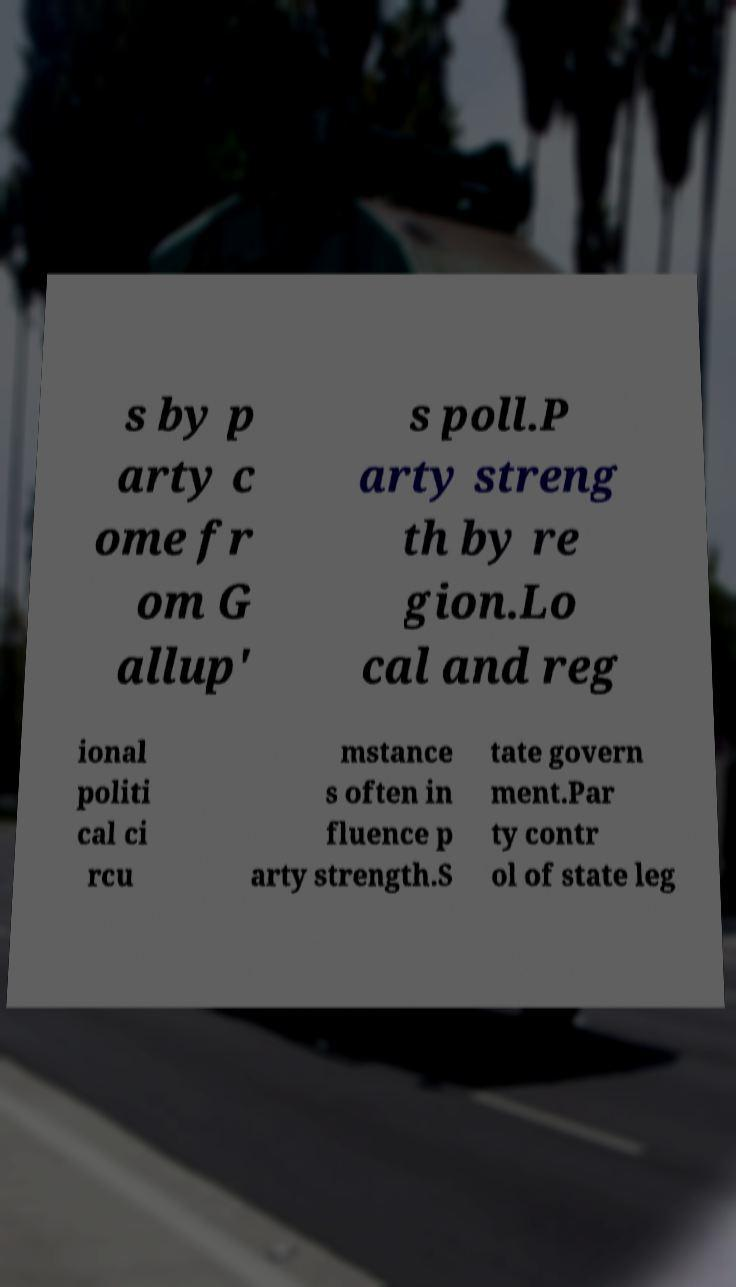For documentation purposes, I need the text within this image transcribed. Could you provide that? s by p arty c ome fr om G allup' s poll.P arty streng th by re gion.Lo cal and reg ional politi cal ci rcu mstance s often in fluence p arty strength.S tate govern ment.Par ty contr ol of state leg 